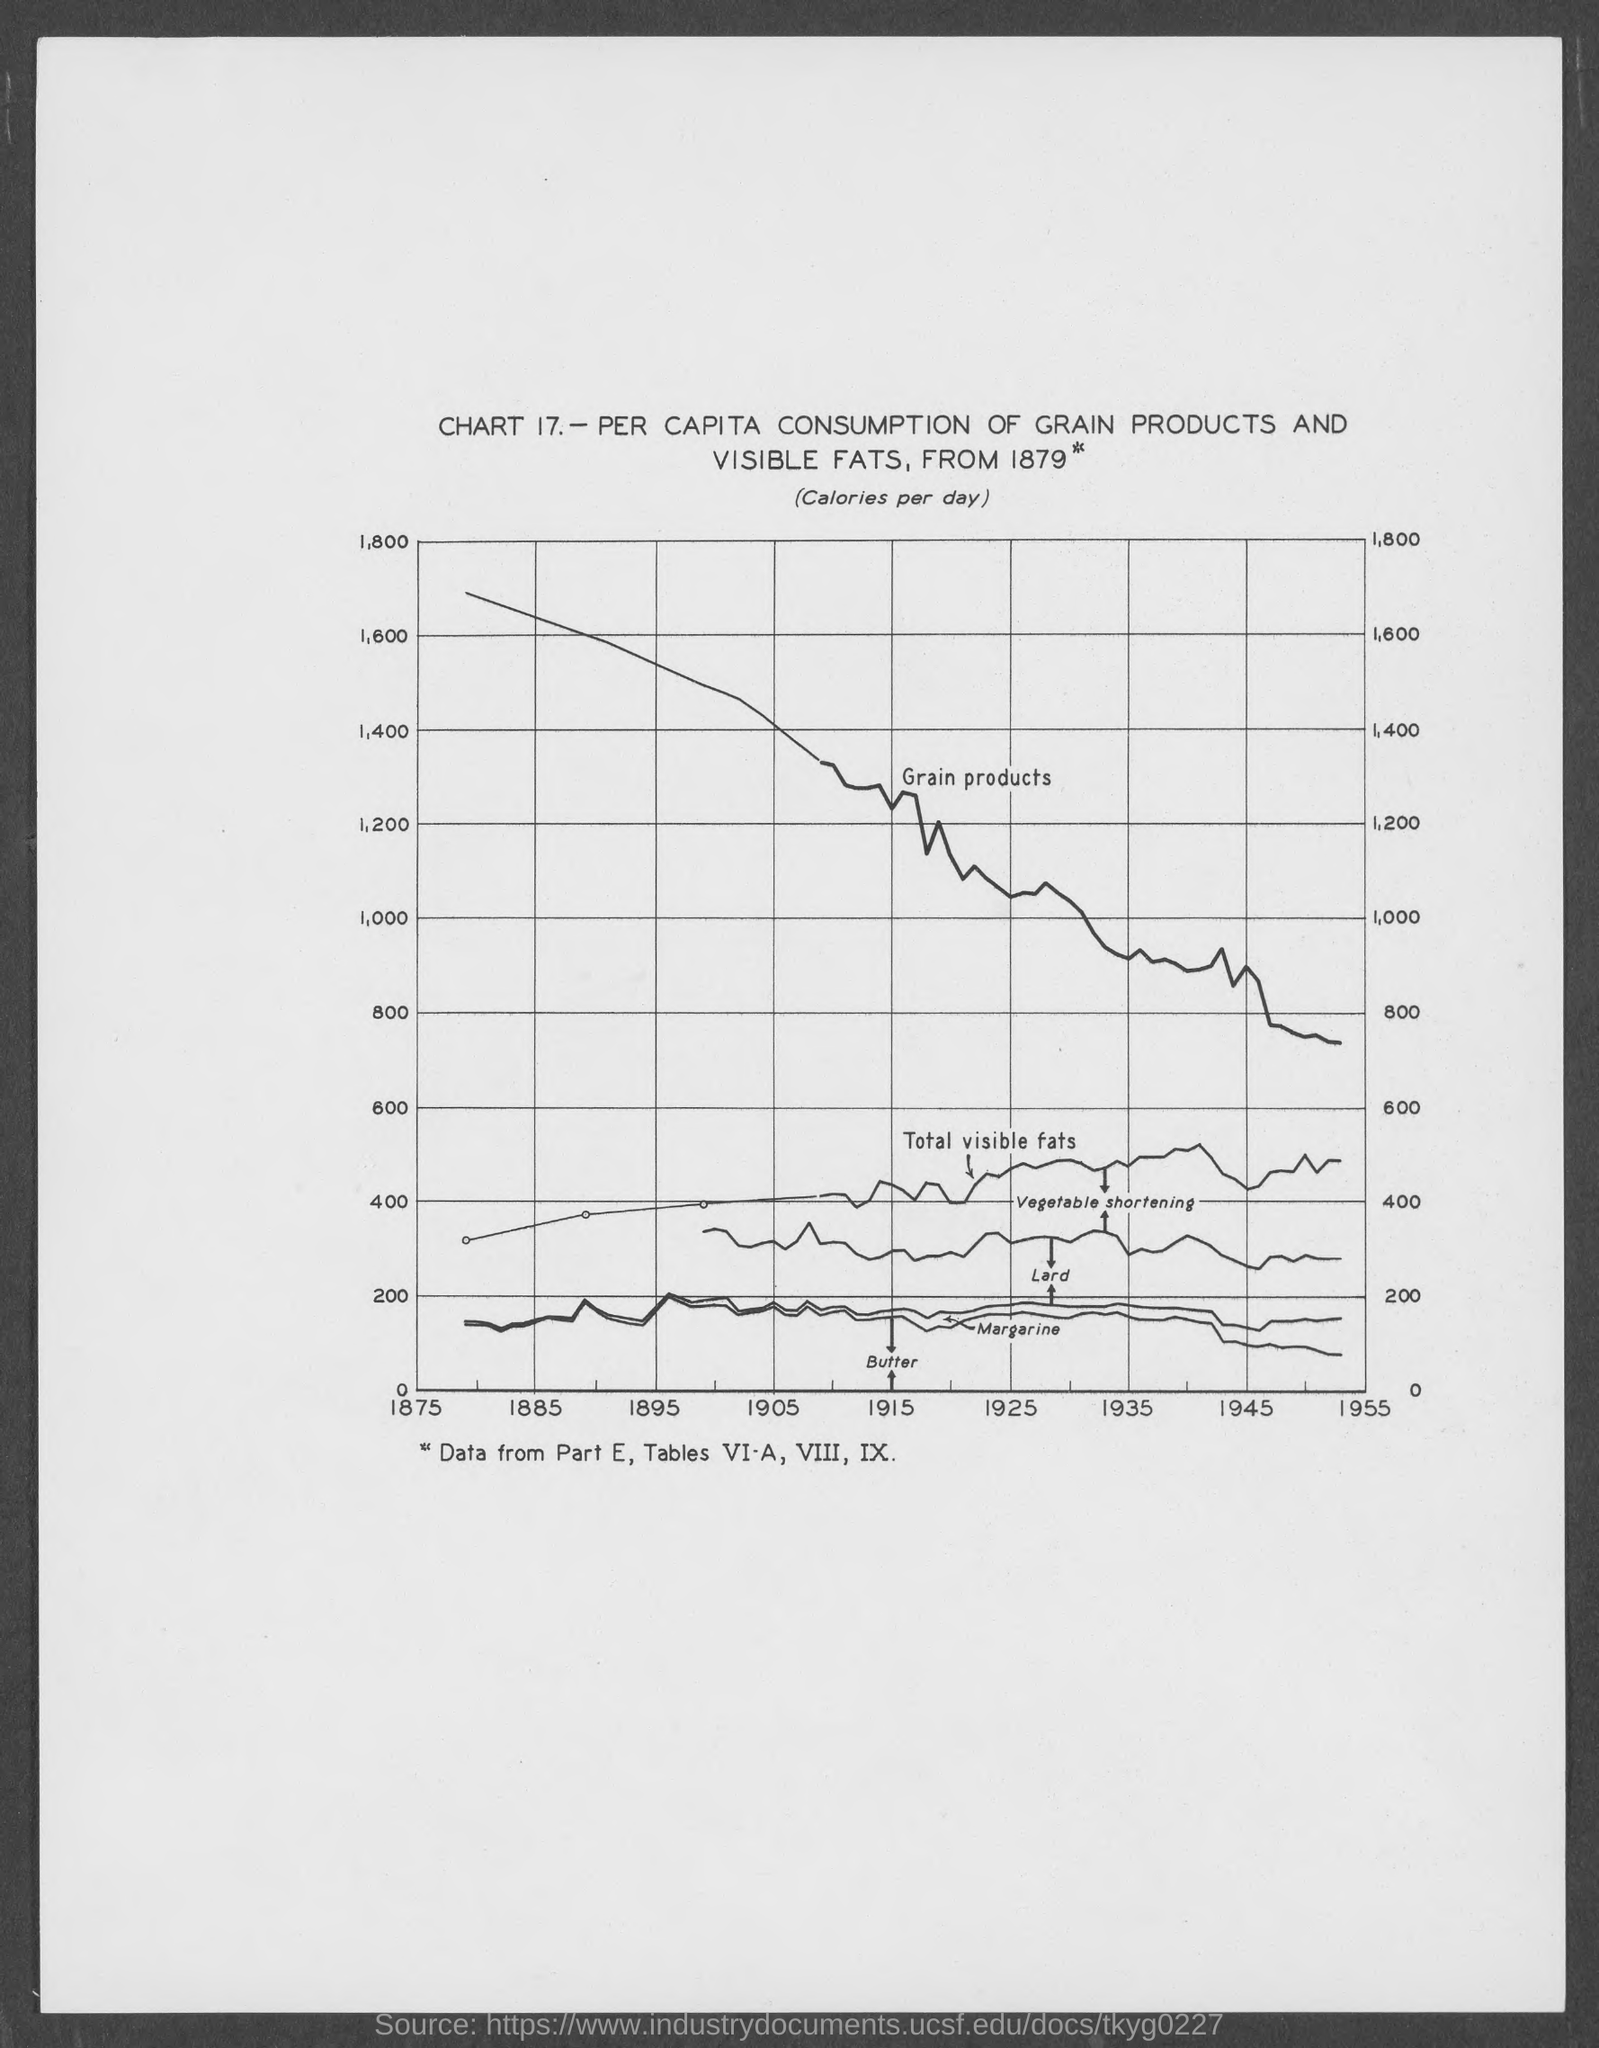What is the chart number?
Your answer should be very brief. 17. 